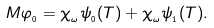Convert formula to latex. <formula><loc_0><loc_0><loc_500><loc_500>M \varphi _ { _ { 0 } } = \chi _ { _ { \omega } } \psi _ { _ { 0 } } ( T ) + \chi _ { _ { \omega } } \psi _ { _ { 1 } } ( T ) .</formula> 